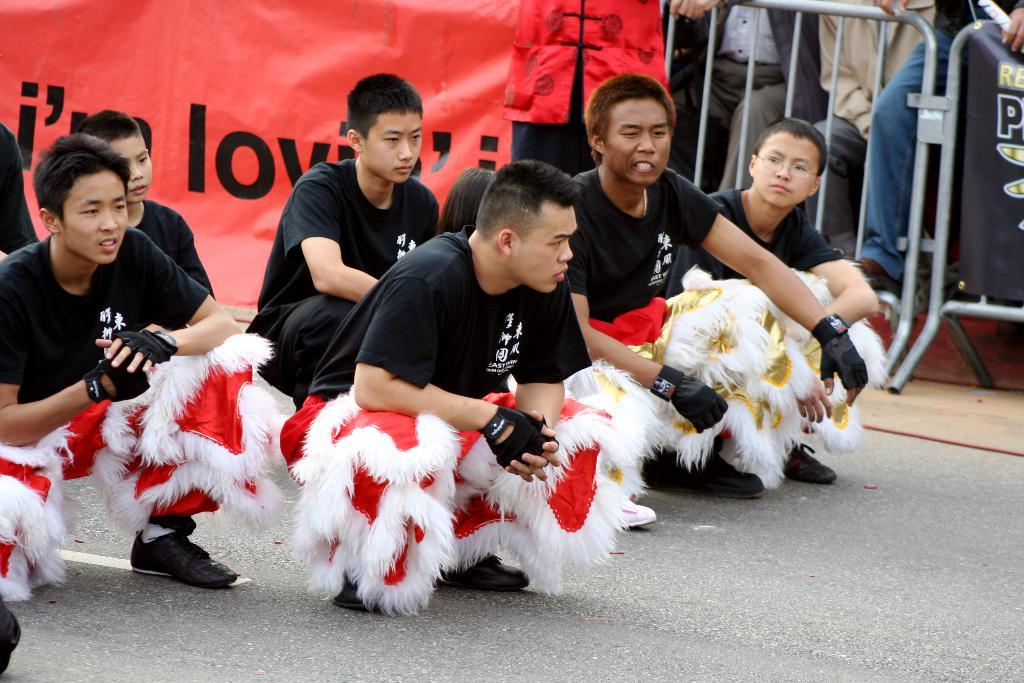What can be seen in the background of the image? There are barricades and banners in the background of the image. What are the people in the image wearing? The people in the image are wearing the same attire. What is the bottom portion of the image showing? The bottom portion of the image contains a road. What type of blade is being used by the yak in the image? There is no yak or blade present in the image. How does the image move or change over time? The image is a static representation and does not move or change over time. 